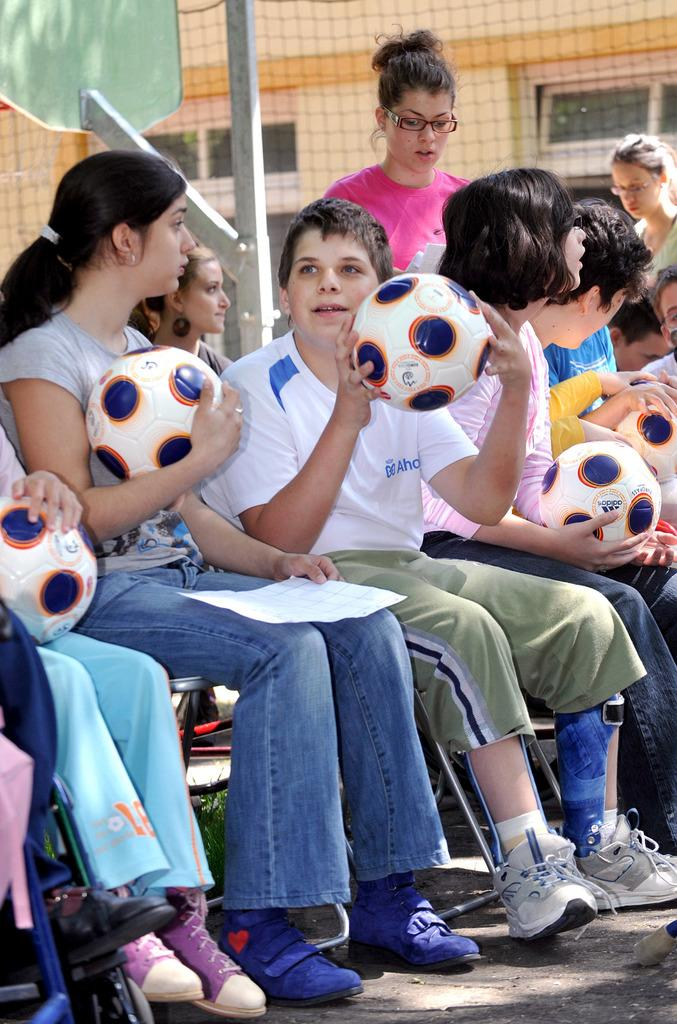What is happening in the image involving the group of people? The people in the image are seated and holding footballs. Are there any people standing in the image? Yes, two people are standing in the image. What can be seen in the background or surrounding the group of people? There is a net in the image. What type of pies are being served to the people in the image? There is no mention of pies in the image; the people are holding footballs. 